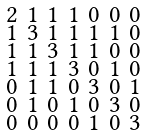<formula> <loc_0><loc_0><loc_500><loc_500>\begin{smallmatrix} 2 & 1 & 1 & 1 & 0 & 0 & 0 \\ 1 & 3 & 1 & 1 & 1 & 1 & 0 \\ 1 & 1 & 3 & 1 & 1 & 0 & 0 \\ 1 & 1 & 1 & 3 & 0 & 1 & 0 \\ 0 & 1 & 1 & 0 & 3 & 0 & 1 \\ 0 & 1 & 0 & 1 & 0 & 3 & 0 \\ 0 & 0 & 0 & 0 & 1 & 0 & 3 \end{smallmatrix}</formula> 